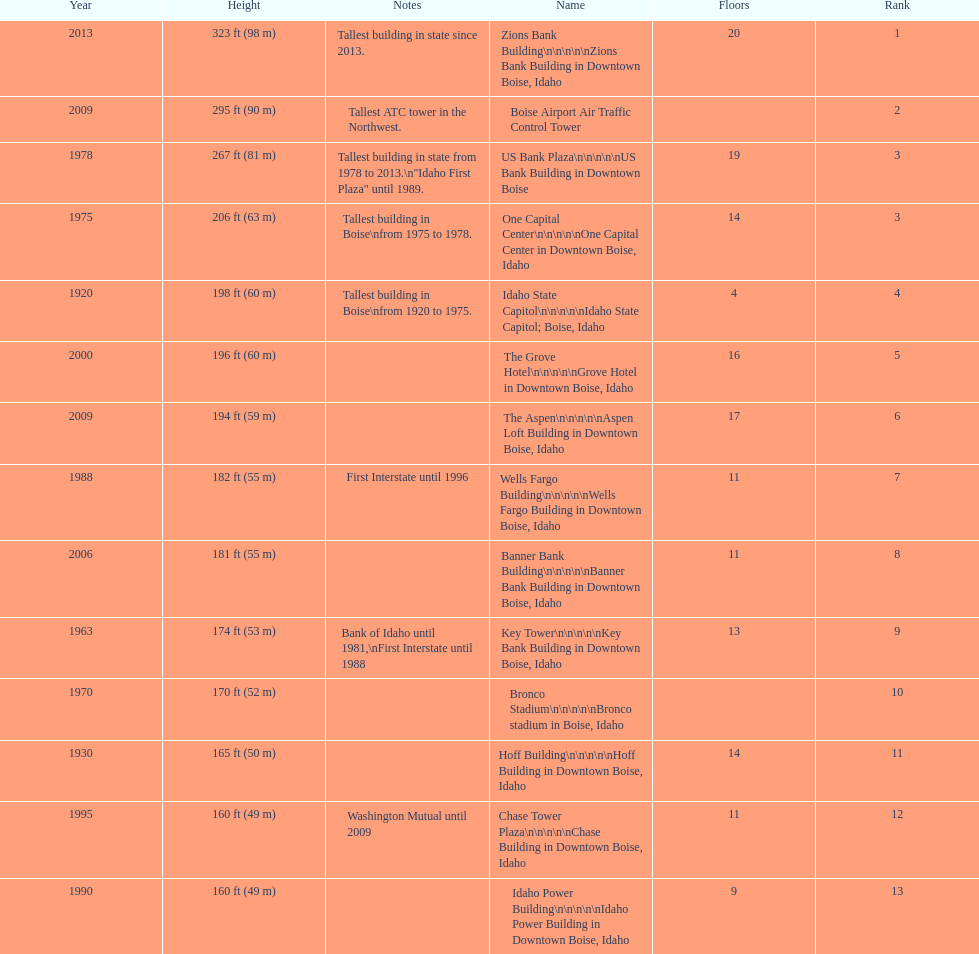Would you mind parsing the complete table? {'header': ['Year', 'Height', 'Notes', 'Name', 'Floors', 'Rank'], 'rows': [['2013', '323\xa0ft (98\xa0m)', 'Tallest building in state since 2013.', 'Zions Bank Building\\n\\n\\n\\n\\nZions Bank Building in Downtown Boise, Idaho', '20', '1'], ['2009', '295\xa0ft (90\xa0m)', 'Tallest ATC tower in the Northwest.', 'Boise Airport Air Traffic Control Tower', '', '2'], ['1978', '267\xa0ft (81\xa0m)', 'Tallest building in state from 1978 to 2013.\\n"Idaho First Plaza" until 1989.', 'US Bank Plaza\\n\\n\\n\\n\\nUS Bank Building in Downtown Boise', '19', '3'], ['1975', '206\xa0ft (63\xa0m)', 'Tallest building in Boise\\nfrom 1975 to 1978.', 'One Capital Center\\n\\n\\n\\n\\nOne Capital Center in Downtown Boise, Idaho', '14', '3'], ['1920', '198\xa0ft (60\xa0m)', 'Tallest building in Boise\\nfrom 1920 to 1975.', 'Idaho State Capitol\\n\\n\\n\\n\\nIdaho State Capitol; Boise, Idaho', '4', '4'], ['2000', '196\xa0ft (60\xa0m)', '', 'The Grove Hotel\\n\\n\\n\\n\\nGrove Hotel in Downtown Boise, Idaho', '16', '5'], ['2009', '194\xa0ft (59\xa0m)', '', 'The Aspen\\n\\n\\n\\n\\nAspen Loft Building in Downtown Boise, Idaho', '17', '6'], ['1988', '182\xa0ft (55\xa0m)', 'First Interstate until 1996', 'Wells Fargo Building\\n\\n\\n\\n\\nWells Fargo Building in Downtown Boise, Idaho', '11', '7'], ['2006', '181\xa0ft (55\xa0m)', '', 'Banner Bank Building\\n\\n\\n\\n\\nBanner Bank Building in Downtown Boise, Idaho', '11', '8'], ['1963', '174\xa0ft (53\xa0m)', 'Bank of Idaho until 1981,\\nFirst Interstate until 1988', 'Key Tower\\n\\n\\n\\n\\nKey Bank Building in Downtown Boise, Idaho', '13', '9'], ['1970', '170\xa0ft (52\xa0m)', '', 'Bronco Stadium\\n\\n\\n\\n\\nBronco stadium in Boise, Idaho', '', '10'], ['1930', '165\xa0ft (50\xa0m)', '', 'Hoff Building\\n\\n\\n\\n\\nHoff Building in Downtown Boise, Idaho', '14', '11'], ['1995', '160\xa0ft (49\xa0m)', 'Washington Mutual until 2009', 'Chase Tower Plaza\\n\\n\\n\\n\\nChase Building in Downtown Boise, Idaho', '11', '12'], ['1990', '160\xa0ft (49\xa0m)', '', 'Idaho Power Building\\n\\n\\n\\n\\nIdaho Power Building in Downtown Boise, Idaho', '9', '13']]} Is the bronco stadium above or below 150 ft? Above. 